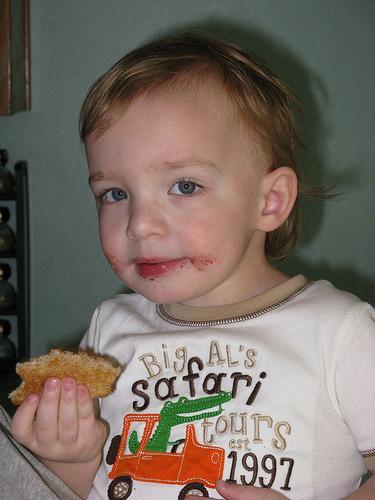Question: why is the child eating?
Choices:
A. He is starving.
B. He is hungry.
C. He is bored.
D. He enjoys the taste.
Answer with the letter. Answer: B Question: when was Big Al's Safari tours established?
Choices:
A. 1996.
B. 1998.
C. 1997.
D. 1999.
Answer with the letter. Answer: C Question: where was this photo taken?
Choices:
A. In a church.
B. In a bar.
C. In a home.
D. In a pool hall.
Answer with the letter. Answer: C Question: who is eating toast?
Choices:
A. The toddler.
B. The child.
C. The boy.
D. The girl.
Answer with the letter. Answer: B Question: what color is the child's shirt?
Choices:
A. Teal.
B. Purple.
C. White.
D. Neon.
Answer with the letter. Answer: C 